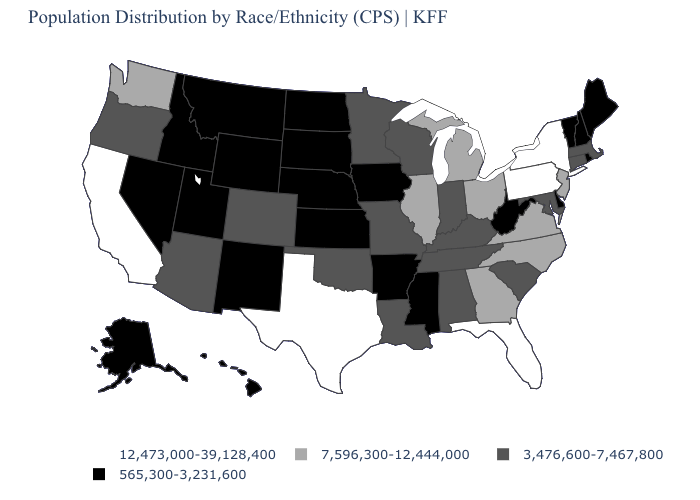What is the value of Kansas?
Concise answer only. 565,300-3,231,600. Name the states that have a value in the range 565,300-3,231,600?
Short answer required. Alaska, Arkansas, Delaware, Hawaii, Idaho, Iowa, Kansas, Maine, Mississippi, Montana, Nebraska, Nevada, New Hampshire, New Mexico, North Dakota, Rhode Island, South Dakota, Utah, Vermont, West Virginia, Wyoming. What is the value of Florida?
Concise answer only. 12,473,000-39,128,400. Which states have the lowest value in the South?
Concise answer only. Arkansas, Delaware, Mississippi, West Virginia. Name the states that have a value in the range 12,473,000-39,128,400?
Be succinct. California, Florida, New York, Pennsylvania, Texas. Among the states that border Oregon , which have the highest value?
Write a very short answer. California. Name the states that have a value in the range 7,596,300-12,444,000?
Keep it brief. Georgia, Illinois, Michigan, New Jersey, North Carolina, Ohio, Virginia, Washington. Which states have the lowest value in the Northeast?
Answer briefly. Maine, New Hampshire, Rhode Island, Vermont. What is the value of Vermont?
Keep it brief. 565,300-3,231,600. What is the lowest value in the South?
Quick response, please. 565,300-3,231,600. Among the states that border Vermont , does New York have the highest value?
Short answer required. Yes. What is the lowest value in states that border Idaho?
Short answer required. 565,300-3,231,600. Does New York have the highest value in the USA?
Keep it brief. Yes. What is the value of Alaska?
Keep it brief. 565,300-3,231,600. Among the states that border New Hampshire , which have the lowest value?
Short answer required. Maine, Vermont. 